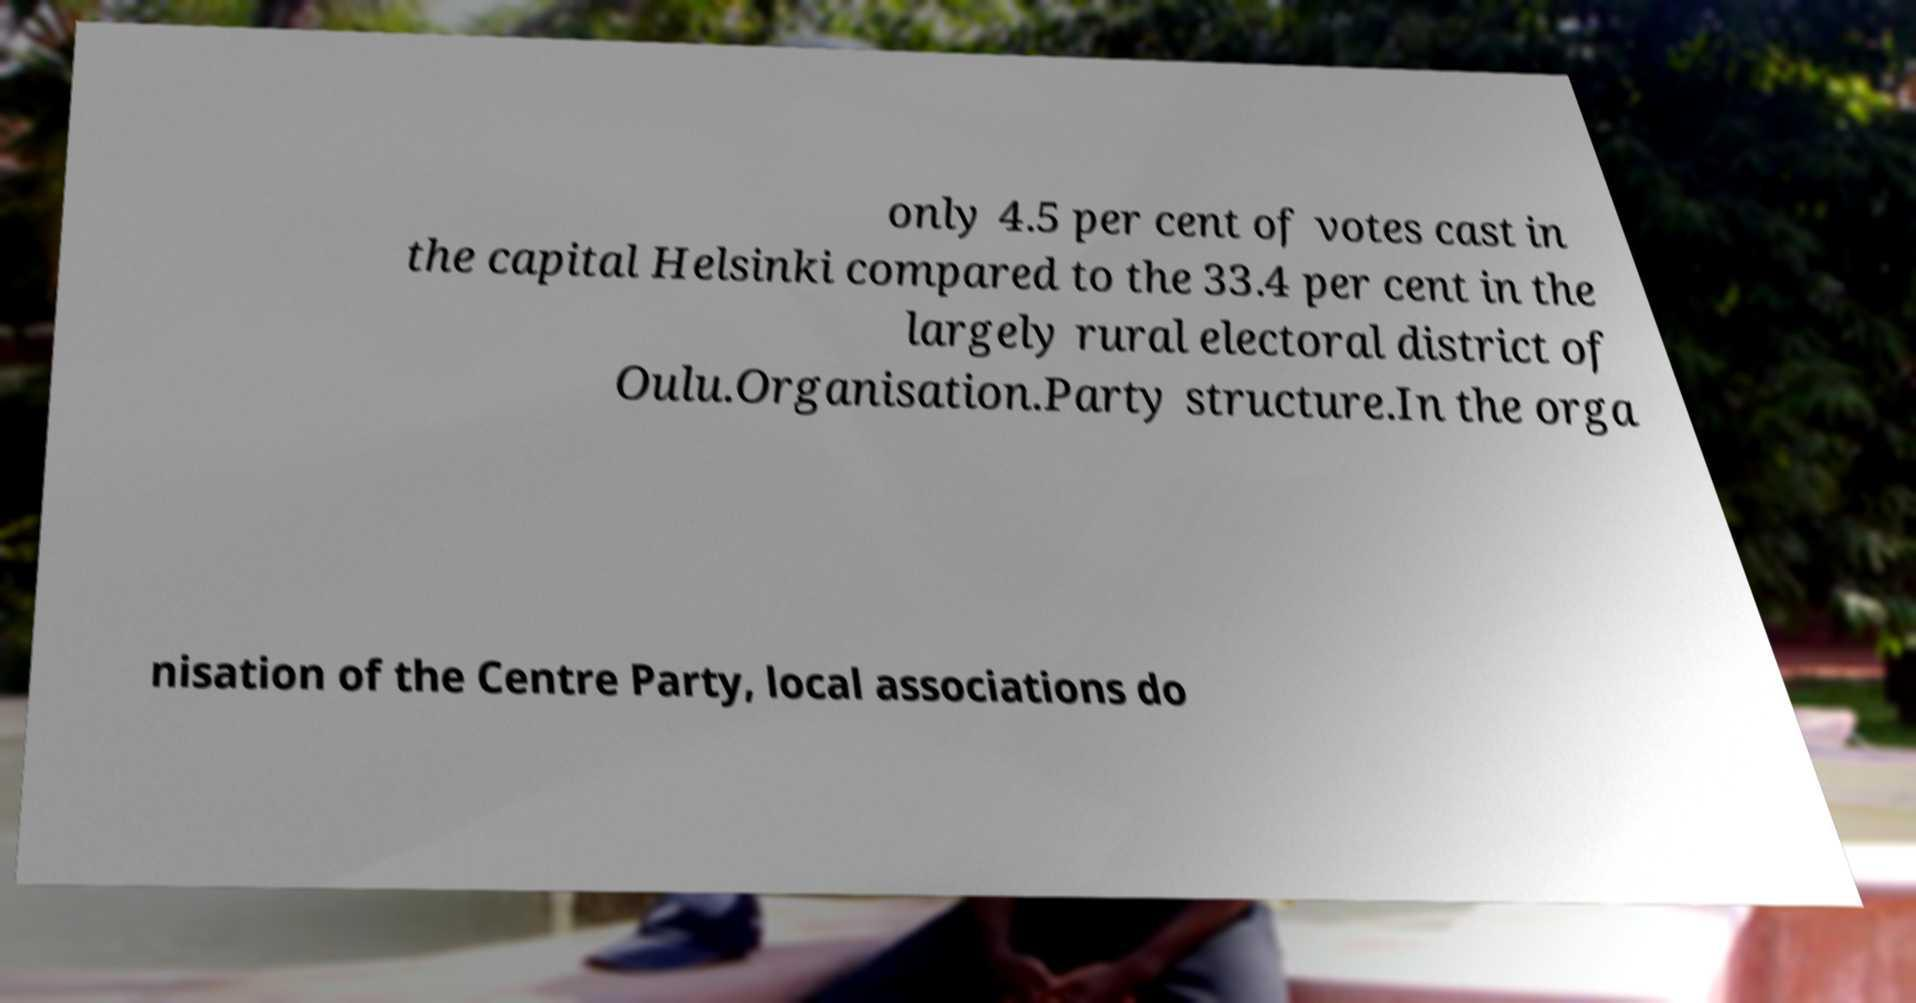Can you accurately transcribe the text from the provided image for me? only 4.5 per cent of votes cast in the capital Helsinki compared to the 33.4 per cent in the largely rural electoral district of Oulu.Organisation.Party structure.In the orga nisation of the Centre Party, local associations do 